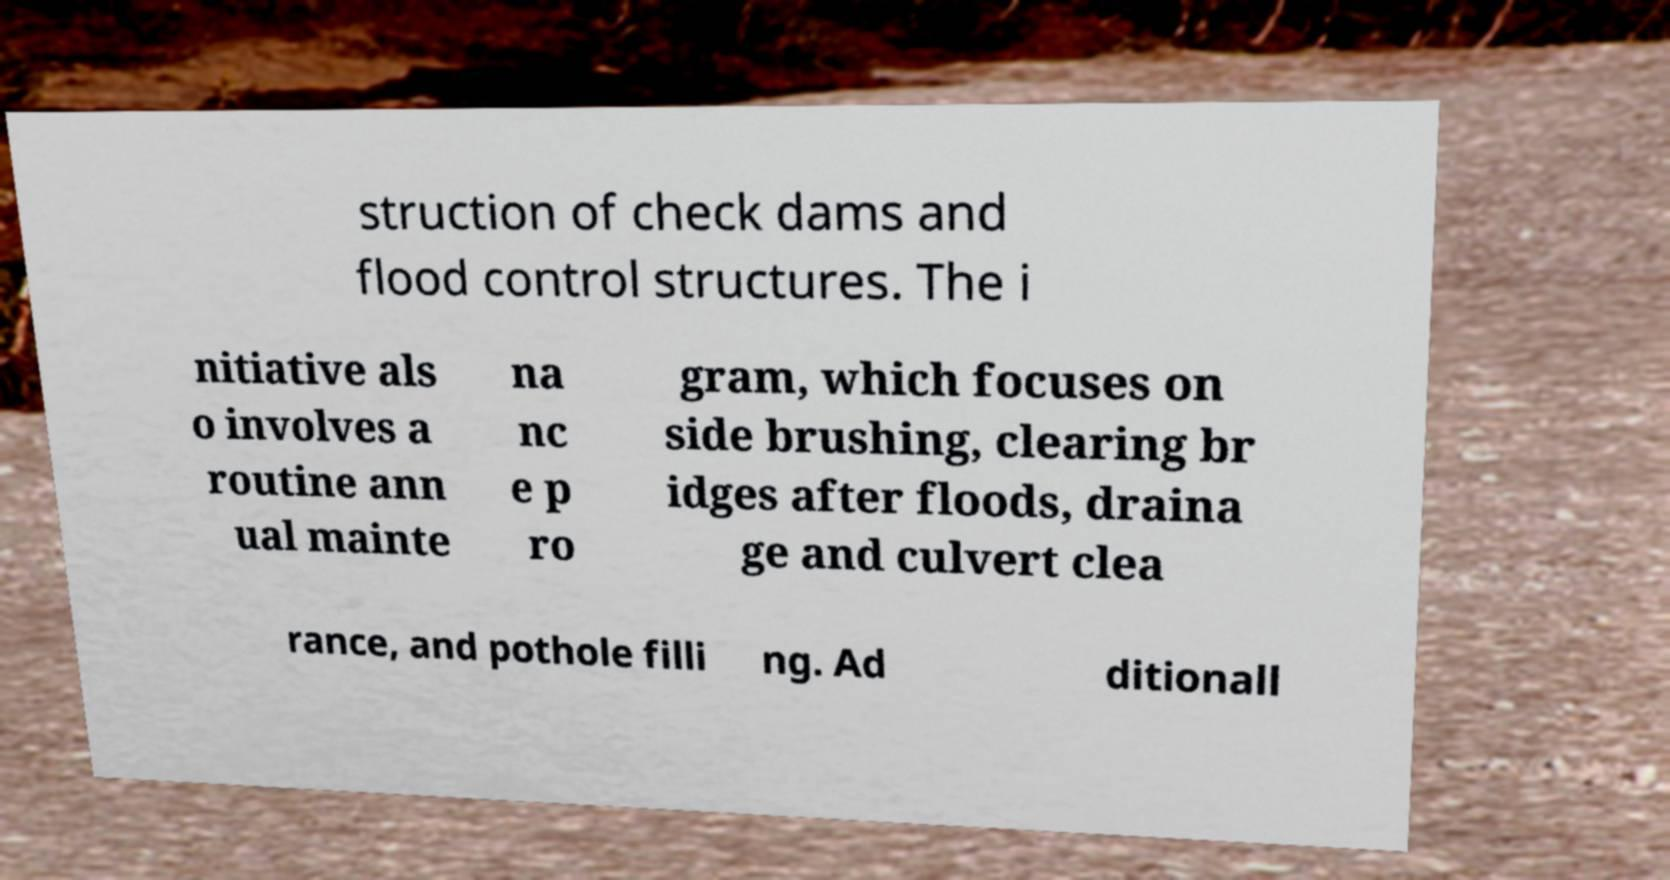Could you extract and type out the text from this image? struction of check dams and flood control structures. The i nitiative als o involves a routine ann ual mainte na nc e p ro gram, which focuses on side brushing, clearing br idges after floods, draina ge and culvert clea rance, and pothole filli ng. Ad ditionall 